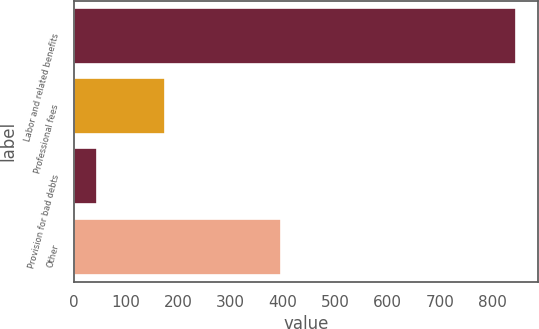<chart> <loc_0><loc_0><loc_500><loc_500><bar_chart><fcel>Labor and related benefits<fcel>Professional fees<fcel>Provision for bad debts<fcel>Other<nl><fcel>845<fcel>175<fcel>45<fcel>396<nl></chart> 